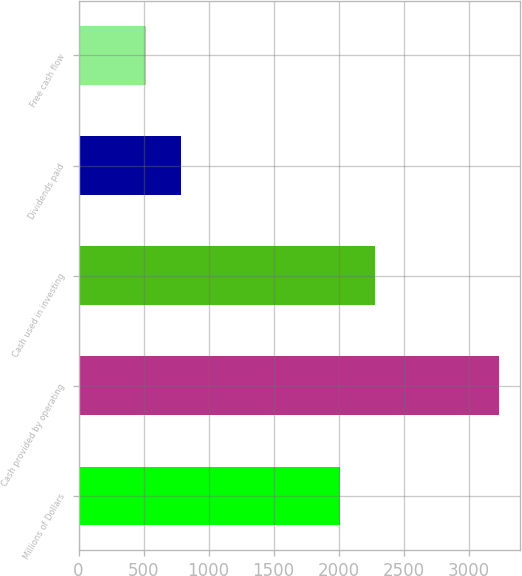Convert chart. <chart><loc_0><loc_0><loc_500><loc_500><bar_chart><fcel>Millions of Dollars<fcel>Cash provided by operating<fcel>Cash used in investing<fcel>Dividends paid<fcel>Free cash flow<nl><fcel>2009<fcel>3234<fcel>2280.9<fcel>786.9<fcel>515<nl></chart> 